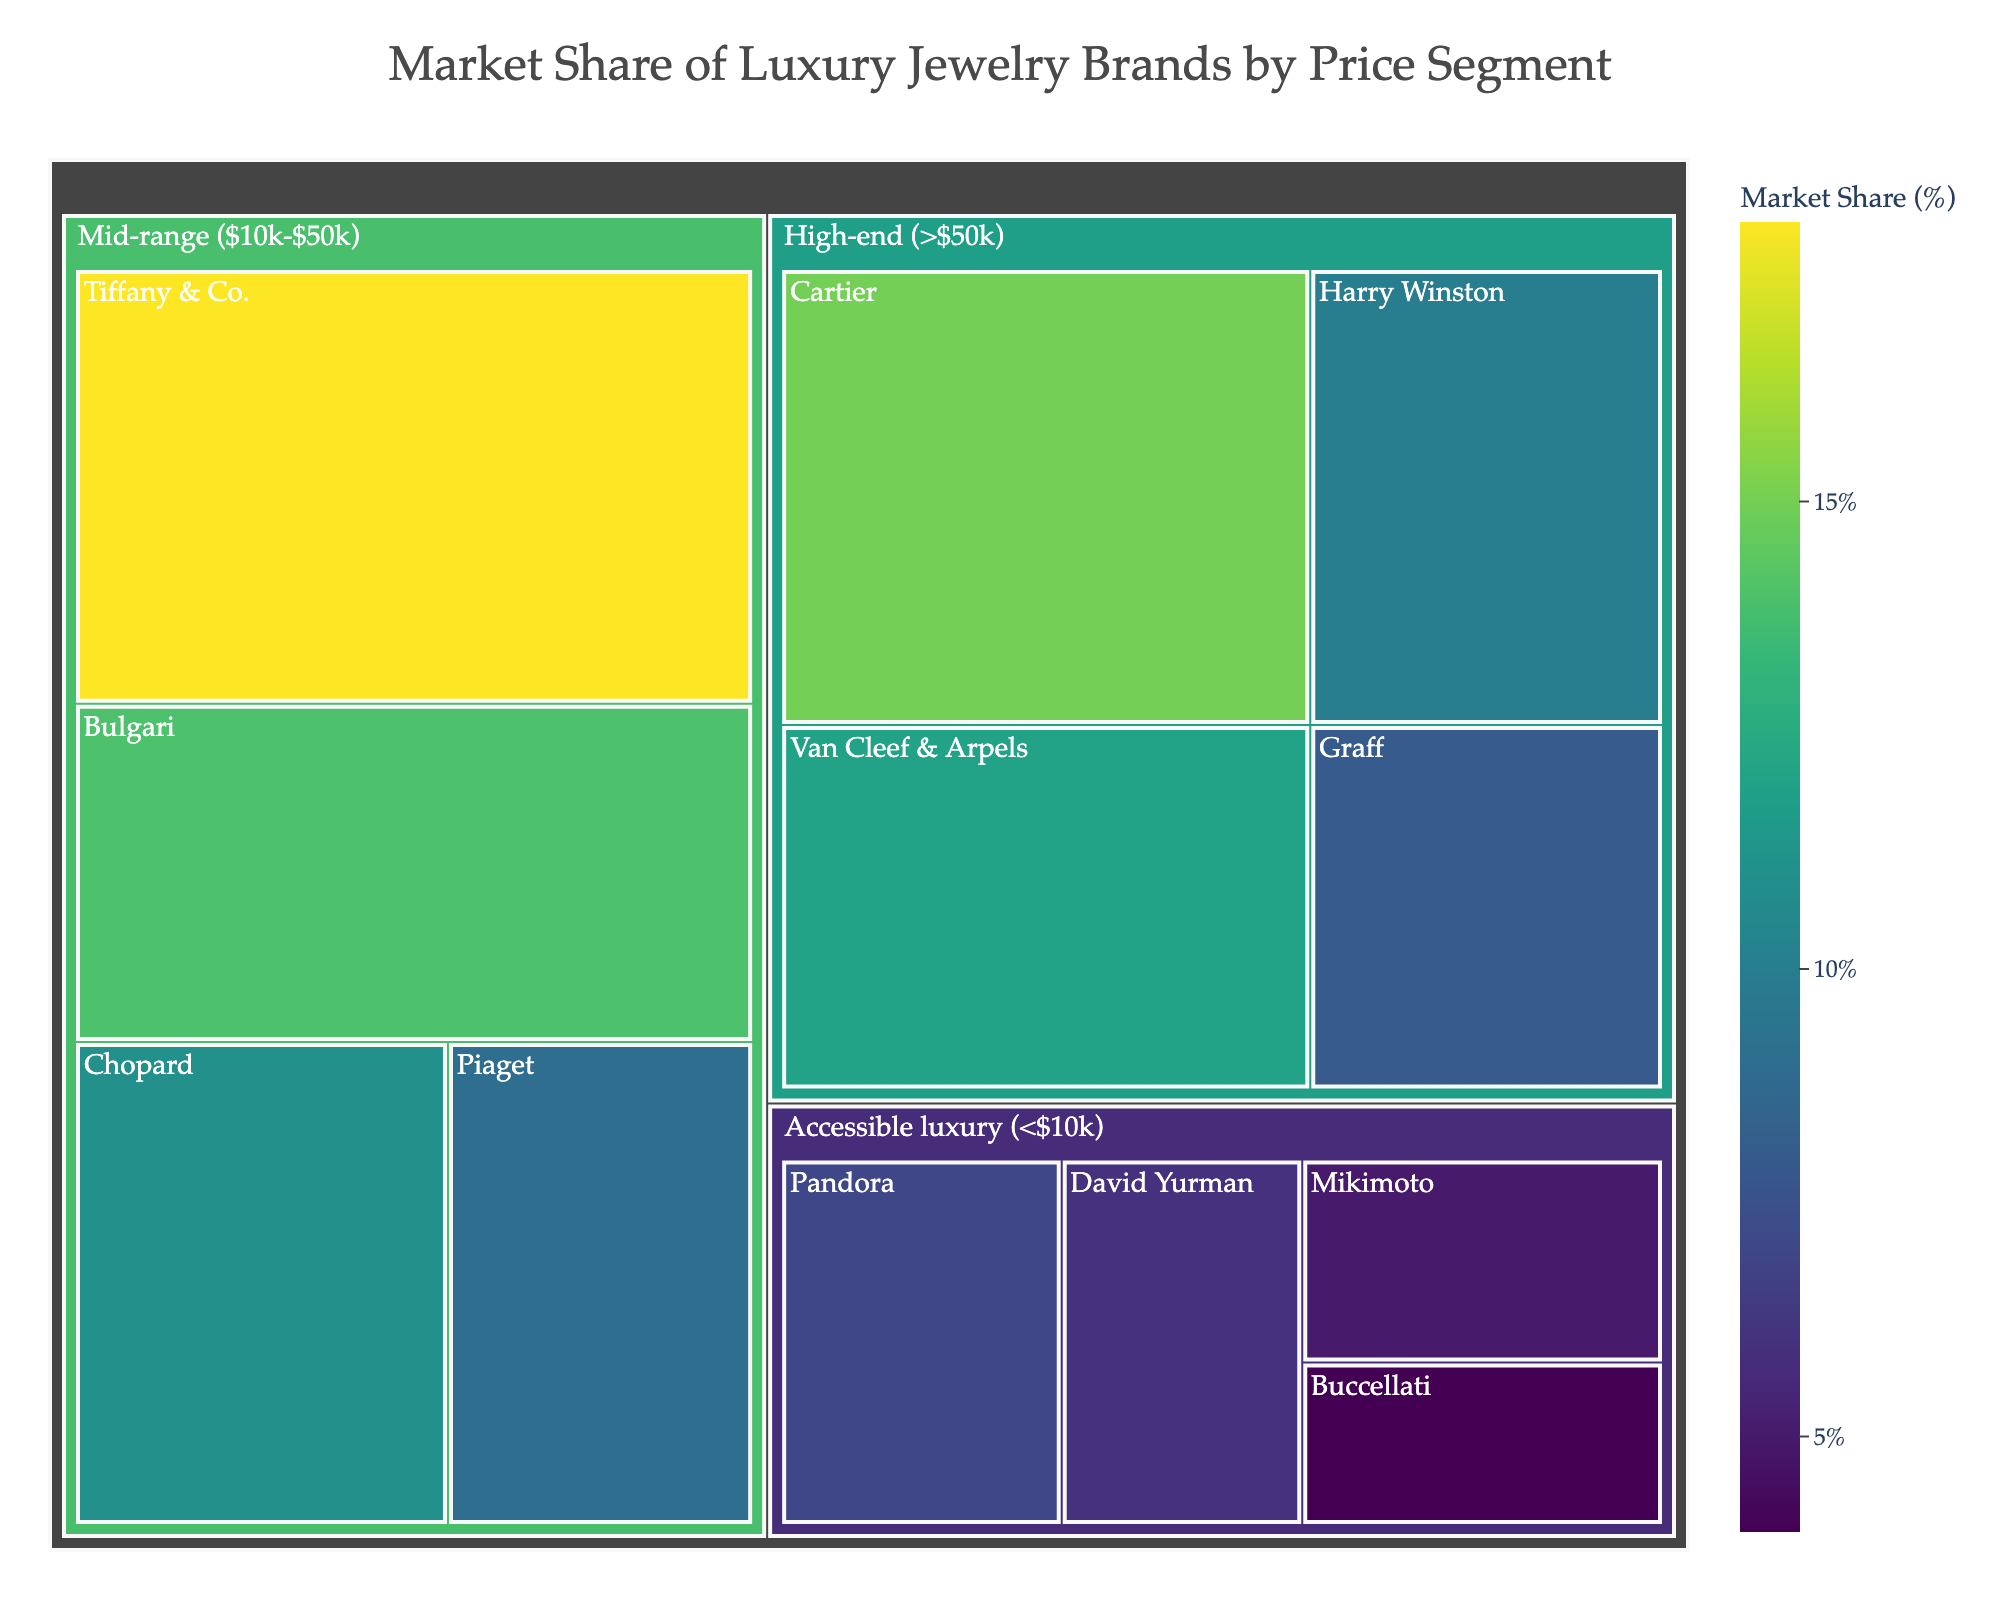Which price segment has the highest market share for a single brand? To find this, look at the largest individual section within each price segment. The largest single segment is Tiffany & Co. in the mid-range ($10k-$50k) category.
Answer: Mid-range ($10k-$50k) What is the total market share of brands in the high-end segment? To determine the total market share, sum up the market shares in the high-end (>$50k) category: Cartier (15) + Van Cleef & Arpels (12) + Harry Winston (10) + Graff (8) = 45%.
Answer: 45% Which brand has the smallest market share in the accessible luxury segment? Look at the accessible luxury (<$10k) category and identify the smallest segment. Buccellati has the smallest market share in this segment.
Answer: Buccellati How do the market shares of Cartier and Van Cleef & Arpels compare? Compare the market shares of these two brands in the high-end (> $50k) category. Cartier has 15% and Van Cleef & Arpels has 12%, so Cartier has a higher market share.
Answer: Cartier has a higher market share What is the average market share of brands in the mid-range segment? Sum the market shares in the mid-range ($10k-$50k) category and divide by the number of brands: (18 + 14 + 11 + 9) / 4 = 52 / 4 = 13%.
Answer: 13% How does the market share of Harry Winston compare to Graff? Compare the market shares of these two brands in the high-end (> $50k) category. Harry Winston has 10% and Graff has 8%, so Harry Winston has a higher market share.
Answer: Harry Winston has a higher market share Which price segment contains the most brands? Compare the number of brands in each category. The mid-range ($10k-$50k) category has four brands, which is more than the other categories.
Answer: Mid-range ($10k-$50k) Which price category shows the greatest market share difference between the largest and smallest brand? Calculate the differences for each category and find the greatest. High-end: 15 - 8 = 7%, Mid-range: 18 - 9 = 9%, Accessible luxury: 7 - 4 = 3%. The mid-range category has the greatest market share difference of 9%.
Answer: Mid-range ($10k-$50k) What color scale is used to represent market share in the figure? The color scale used to represent market share in the treemap is the 'Viridis' scale.
Answer: Viridis 